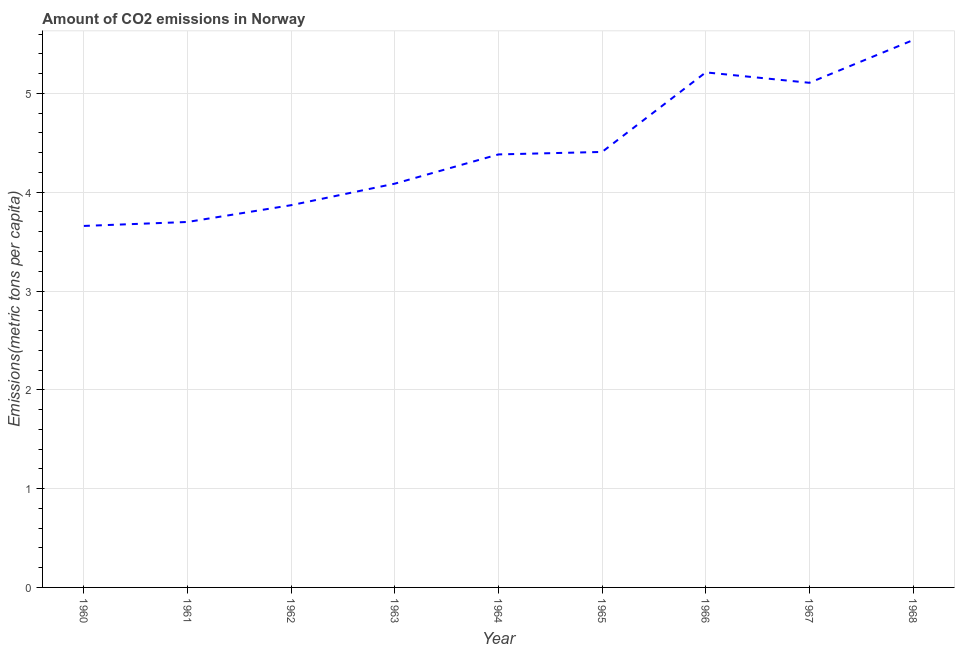What is the amount of co2 emissions in 1961?
Your response must be concise. 3.7. Across all years, what is the maximum amount of co2 emissions?
Offer a very short reply. 5.54. Across all years, what is the minimum amount of co2 emissions?
Keep it short and to the point. 3.66. In which year was the amount of co2 emissions maximum?
Give a very brief answer. 1968. In which year was the amount of co2 emissions minimum?
Provide a short and direct response. 1960. What is the sum of the amount of co2 emissions?
Offer a terse response. 39.96. What is the difference between the amount of co2 emissions in 1963 and 1968?
Offer a terse response. -1.45. What is the average amount of co2 emissions per year?
Ensure brevity in your answer.  4.44. What is the median amount of co2 emissions?
Ensure brevity in your answer.  4.38. Do a majority of the years between 1964 and 1963 (inclusive) have amount of co2 emissions greater than 2.4 metric tons per capita?
Provide a succinct answer. No. What is the ratio of the amount of co2 emissions in 1962 to that in 1963?
Provide a short and direct response. 0.95. Is the difference between the amount of co2 emissions in 1962 and 1963 greater than the difference between any two years?
Provide a short and direct response. No. What is the difference between the highest and the second highest amount of co2 emissions?
Provide a short and direct response. 0.33. What is the difference between the highest and the lowest amount of co2 emissions?
Your response must be concise. 1.88. In how many years, is the amount of co2 emissions greater than the average amount of co2 emissions taken over all years?
Provide a short and direct response. 3. Are the values on the major ticks of Y-axis written in scientific E-notation?
Your answer should be compact. No. Does the graph contain any zero values?
Give a very brief answer. No. Does the graph contain grids?
Offer a terse response. Yes. What is the title of the graph?
Your answer should be very brief. Amount of CO2 emissions in Norway. What is the label or title of the Y-axis?
Provide a succinct answer. Emissions(metric tons per capita). What is the Emissions(metric tons per capita) of 1960?
Provide a short and direct response. 3.66. What is the Emissions(metric tons per capita) of 1961?
Give a very brief answer. 3.7. What is the Emissions(metric tons per capita) of 1962?
Provide a succinct answer. 3.87. What is the Emissions(metric tons per capita) of 1963?
Your response must be concise. 4.09. What is the Emissions(metric tons per capita) of 1964?
Ensure brevity in your answer.  4.38. What is the Emissions(metric tons per capita) of 1965?
Provide a succinct answer. 4.41. What is the Emissions(metric tons per capita) of 1966?
Keep it short and to the point. 5.21. What is the Emissions(metric tons per capita) of 1967?
Provide a short and direct response. 5.11. What is the Emissions(metric tons per capita) of 1968?
Provide a short and direct response. 5.54. What is the difference between the Emissions(metric tons per capita) in 1960 and 1961?
Your answer should be compact. -0.04. What is the difference between the Emissions(metric tons per capita) in 1960 and 1962?
Ensure brevity in your answer.  -0.21. What is the difference between the Emissions(metric tons per capita) in 1960 and 1963?
Provide a short and direct response. -0.43. What is the difference between the Emissions(metric tons per capita) in 1960 and 1964?
Make the answer very short. -0.72. What is the difference between the Emissions(metric tons per capita) in 1960 and 1965?
Offer a terse response. -0.75. What is the difference between the Emissions(metric tons per capita) in 1960 and 1966?
Your answer should be very brief. -1.55. What is the difference between the Emissions(metric tons per capita) in 1960 and 1967?
Give a very brief answer. -1.45. What is the difference between the Emissions(metric tons per capita) in 1960 and 1968?
Keep it short and to the point. -1.88. What is the difference between the Emissions(metric tons per capita) in 1961 and 1962?
Provide a short and direct response. -0.17. What is the difference between the Emissions(metric tons per capita) in 1961 and 1963?
Make the answer very short. -0.39. What is the difference between the Emissions(metric tons per capita) in 1961 and 1964?
Give a very brief answer. -0.68. What is the difference between the Emissions(metric tons per capita) in 1961 and 1965?
Give a very brief answer. -0.71. What is the difference between the Emissions(metric tons per capita) in 1961 and 1966?
Your answer should be very brief. -1.51. What is the difference between the Emissions(metric tons per capita) in 1961 and 1967?
Ensure brevity in your answer.  -1.41. What is the difference between the Emissions(metric tons per capita) in 1961 and 1968?
Offer a terse response. -1.84. What is the difference between the Emissions(metric tons per capita) in 1962 and 1963?
Your answer should be very brief. -0.22. What is the difference between the Emissions(metric tons per capita) in 1962 and 1964?
Provide a succinct answer. -0.51. What is the difference between the Emissions(metric tons per capita) in 1962 and 1965?
Provide a succinct answer. -0.54. What is the difference between the Emissions(metric tons per capita) in 1962 and 1966?
Ensure brevity in your answer.  -1.34. What is the difference between the Emissions(metric tons per capita) in 1962 and 1967?
Your answer should be compact. -1.24. What is the difference between the Emissions(metric tons per capita) in 1962 and 1968?
Your response must be concise. -1.67. What is the difference between the Emissions(metric tons per capita) in 1963 and 1964?
Ensure brevity in your answer.  -0.3. What is the difference between the Emissions(metric tons per capita) in 1963 and 1965?
Your answer should be very brief. -0.32. What is the difference between the Emissions(metric tons per capita) in 1963 and 1966?
Offer a very short reply. -1.13. What is the difference between the Emissions(metric tons per capita) in 1963 and 1967?
Keep it short and to the point. -1.02. What is the difference between the Emissions(metric tons per capita) in 1963 and 1968?
Your answer should be compact. -1.45. What is the difference between the Emissions(metric tons per capita) in 1964 and 1965?
Make the answer very short. -0.03. What is the difference between the Emissions(metric tons per capita) in 1964 and 1966?
Ensure brevity in your answer.  -0.83. What is the difference between the Emissions(metric tons per capita) in 1964 and 1967?
Your response must be concise. -0.72. What is the difference between the Emissions(metric tons per capita) in 1964 and 1968?
Your answer should be very brief. -1.16. What is the difference between the Emissions(metric tons per capita) in 1965 and 1966?
Your response must be concise. -0.81. What is the difference between the Emissions(metric tons per capita) in 1965 and 1967?
Give a very brief answer. -0.7. What is the difference between the Emissions(metric tons per capita) in 1965 and 1968?
Your response must be concise. -1.13. What is the difference between the Emissions(metric tons per capita) in 1966 and 1967?
Offer a very short reply. 0.11. What is the difference between the Emissions(metric tons per capita) in 1966 and 1968?
Ensure brevity in your answer.  -0.33. What is the difference between the Emissions(metric tons per capita) in 1967 and 1968?
Your answer should be compact. -0.43. What is the ratio of the Emissions(metric tons per capita) in 1960 to that in 1961?
Provide a succinct answer. 0.99. What is the ratio of the Emissions(metric tons per capita) in 1960 to that in 1962?
Provide a succinct answer. 0.95. What is the ratio of the Emissions(metric tons per capita) in 1960 to that in 1963?
Offer a very short reply. 0.9. What is the ratio of the Emissions(metric tons per capita) in 1960 to that in 1964?
Give a very brief answer. 0.83. What is the ratio of the Emissions(metric tons per capita) in 1960 to that in 1965?
Provide a succinct answer. 0.83. What is the ratio of the Emissions(metric tons per capita) in 1960 to that in 1966?
Offer a very short reply. 0.7. What is the ratio of the Emissions(metric tons per capita) in 1960 to that in 1967?
Your answer should be very brief. 0.72. What is the ratio of the Emissions(metric tons per capita) in 1960 to that in 1968?
Offer a terse response. 0.66. What is the ratio of the Emissions(metric tons per capita) in 1961 to that in 1962?
Ensure brevity in your answer.  0.96. What is the ratio of the Emissions(metric tons per capita) in 1961 to that in 1963?
Your answer should be very brief. 0.91. What is the ratio of the Emissions(metric tons per capita) in 1961 to that in 1964?
Your response must be concise. 0.84. What is the ratio of the Emissions(metric tons per capita) in 1961 to that in 1965?
Your response must be concise. 0.84. What is the ratio of the Emissions(metric tons per capita) in 1961 to that in 1966?
Your answer should be very brief. 0.71. What is the ratio of the Emissions(metric tons per capita) in 1961 to that in 1967?
Provide a short and direct response. 0.72. What is the ratio of the Emissions(metric tons per capita) in 1961 to that in 1968?
Make the answer very short. 0.67. What is the ratio of the Emissions(metric tons per capita) in 1962 to that in 1963?
Your response must be concise. 0.95. What is the ratio of the Emissions(metric tons per capita) in 1962 to that in 1964?
Make the answer very short. 0.88. What is the ratio of the Emissions(metric tons per capita) in 1962 to that in 1965?
Make the answer very short. 0.88. What is the ratio of the Emissions(metric tons per capita) in 1962 to that in 1966?
Your answer should be compact. 0.74. What is the ratio of the Emissions(metric tons per capita) in 1962 to that in 1967?
Your answer should be very brief. 0.76. What is the ratio of the Emissions(metric tons per capita) in 1962 to that in 1968?
Make the answer very short. 0.7. What is the ratio of the Emissions(metric tons per capita) in 1963 to that in 1964?
Your answer should be compact. 0.93. What is the ratio of the Emissions(metric tons per capita) in 1963 to that in 1965?
Keep it short and to the point. 0.93. What is the ratio of the Emissions(metric tons per capita) in 1963 to that in 1966?
Your response must be concise. 0.78. What is the ratio of the Emissions(metric tons per capita) in 1963 to that in 1968?
Your answer should be very brief. 0.74. What is the ratio of the Emissions(metric tons per capita) in 1964 to that in 1966?
Provide a short and direct response. 0.84. What is the ratio of the Emissions(metric tons per capita) in 1964 to that in 1967?
Provide a succinct answer. 0.86. What is the ratio of the Emissions(metric tons per capita) in 1964 to that in 1968?
Ensure brevity in your answer.  0.79. What is the ratio of the Emissions(metric tons per capita) in 1965 to that in 1966?
Ensure brevity in your answer.  0.85. What is the ratio of the Emissions(metric tons per capita) in 1965 to that in 1967?
Provide a succinct answer. 0.86. What is the ratio of the Emissions(metric tons per capita) in 1965 to that in 1968?
Your response must be concise. 0.8. What is the ratio of the Emissions(metric tons per capita) in 1966 to that in 1968?
Give a very brief answer. 0.94. What is the ratio of the Emissions(metric tons per capita) in 1967 to that in 1968?
Make the answer very short. 0.92. 